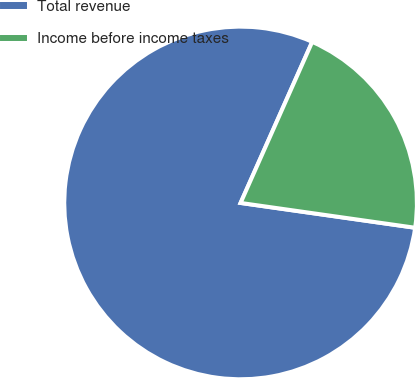Convert chart to OTSL. <chart><loc_0><loc_0><loc_500><loc_500><pie_chart><fcel>Total revenue<fcel>Income before income taxes<nl><fcel>79.41%<fcel>20.59%<nl></chart> 